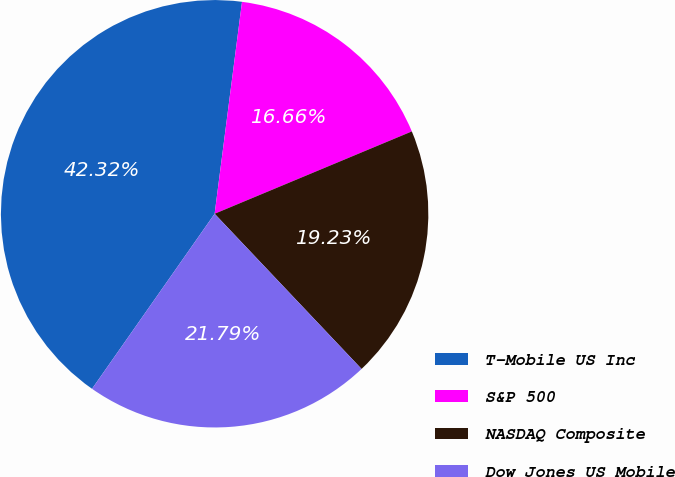<chart> <loc_0><loc_0><loc_500><loc_500><pie_chart><fcel>T-Mobile US Inc<fcel>S&P 500<fcel>NASDAQ Composite<fcel>Dow Jones US Mobile<nl><fcel>42.32%<fcel>16.66%<fcel>19.23%<fcel>21.79%<nl></chart> 